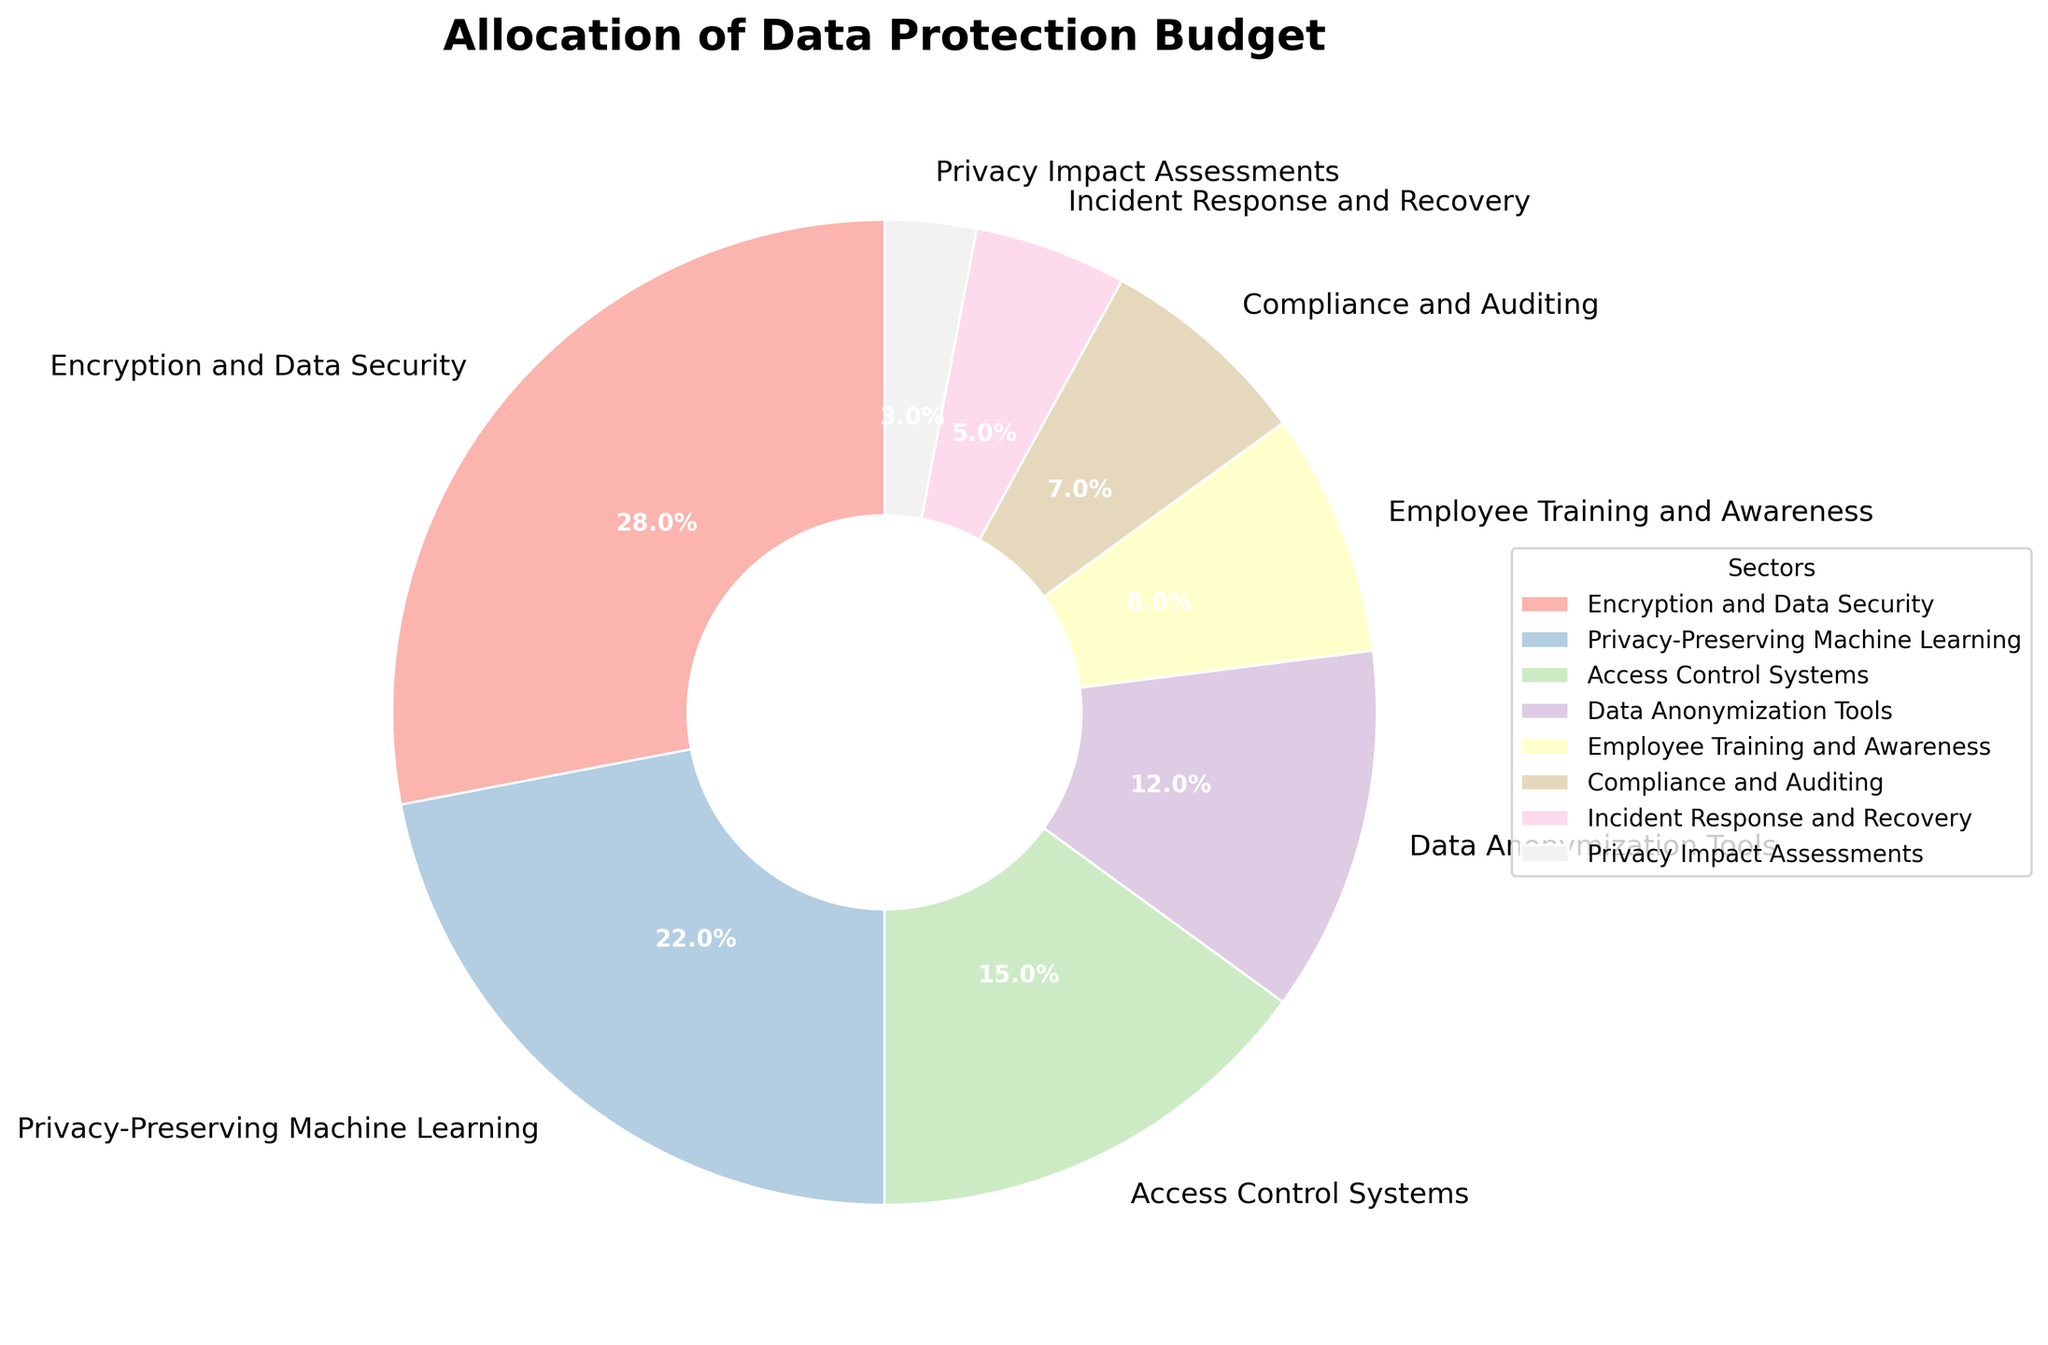Which sector received the highest budget allocation? The sectors are visualized with varying sizes in the pie chart. The segment with the largest size corresponds to the sector with the highest budget allocation. By looking at the chart, "Encryption and Data Security" has the largest segment.
Answer: Encryption and Data Security What percentage of the budget is allocated to Privacy-Preserving Machine Learning? The sectors are labeled with both their names and their budget allocation percentages. Based on the labels, "Privacy-Preserving Machine Learning" has a budget allocation of 22%.
Answer: 22% Which sectors together make up more than half of the total budget allocation? To find which sectors make up more than 50%, sum their percentages until the total exceeds 50%. Starting with the largest, "Encryption and Data Security" (28%) and "Privacy-Preserving Machine Learning" (22%) together sum to 50%. Including any smaller sector like "Access Control Systems" (15%) would push it over 50%.
Answer: Encryption and Data Security, Privacy-Preserving Machine Learning Which sector has the smallest budget allocation and what is its allocated percentage? By identifying the smallest segment in the pie chart, it corresponds to the sector with the smallest budget allocation. The smallest segment is for "Privacy Impact Assessments" with a 3% allocation.
Answer: Privacy Impact Assessments, 3% How does the budget for Employee Training and Awareness compare to the budget for Data Anonymization Tools? Comparing the percentages, Employee Training and Awareness has an 8% allocation, while Data Anonymization Tools has a 12% allocation. The budget for Data Anonymization Tools is higher than for Employee Training and Awareness.
Answer: Data Anonymization Tools is higher What is the combined budget allocation for Compliance and Auditing and Incident Response and Recovery? Sum the percentages for Compliance and Auditing (7%) and Incident Response and Recovery (5%). 7% + 5% = 12%.
Answer: 12% How much more budget percentage is allocated to Encryption and Data Security than to Access Control Systems? Subtract the percentage for Access Control Systems (15%) from the percentage for Encryption and Data Security (28%). 28% - 15% = 13%.
Answer: 13% What is the average budget allocation percentage for all sectors? Sum the percentages and then divide by the number of sectors. The sum is 28 + 22 + 15 + 12 + 8 + 7 + 5 + 3 = 100. There are 8 sectors. The average is 100 / 8 = 12.5%.
Answer: 12.5% What percentage of the budget is allocated to sectors focused purely on technical solutions (Encryption and Data Security, Privacy-Preserving Machine Learning, Access Control Systems, Data Anonymization Tools)? Sum the percentages for these sectors: 28% (Encryption and Data Security), 22% (Privacy-Preserving Machine Learning), 15% (Access Control Systems), 12% (Data Anonymization Tools). 28% + 22% + 15% + 12% = 77%.
Answer: 77% What is the budget difference between the top two sectors, Encryption and Data Security and Privacy-Preserving Machine Learning? Subtract the percentage of Privacy-Preserving Machine Learning (22%) from Encryption and Data Security (28%). 28% - 22% = 6%.
Answer: 6% 